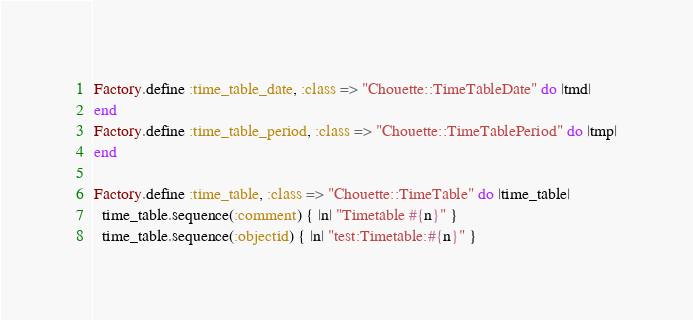Convert code to text. <code><loc_0><loc_0><loc_500><loc_500><_Ruby_>Factory.define :time_table_date, :class => "Chouette::TimeTableDate" do |tmd|
end
Factory.define :time_table_period, :class => "Chouette::TimeTablePeriod" do |tmp|
end

Factory.define :time_table, :class => "Chouette::TimeTable" do |time_table|
  time_table.sequence(:comment) { |n| "Timetable #{n}" }
  time_table.sequence(:objectid) { |n| "test:Timetable:#{n}" }</code> 